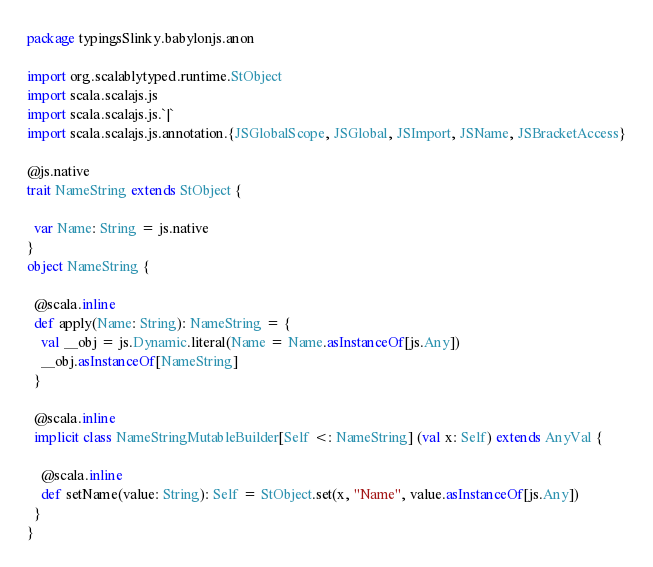Convert code to text. <code><loc_0><loc_0><loc_500><loc_500><_Scala_>package typingsSlinky.babylonjs.anon

import org.scalablytyped.runtime.StObject
import scala.scalajs.js
import scala.scalajs.js.`|`
import scala.scalajs.js.annotation.{JSGlobalScope, JSGlobal, JSImport, JSName, JSBracketAccess}

@js.native
trait NameString extends StObject {
  
  var Name: String = js.native
}
object NameString {
  
  @scala.inline
  def apply(Name: String): NameString = {
    val __obj = js.Dynamic.literal(Name = Name.asInstanceOf[js.Any])
    __obj.asInstanceOf[NameString]
  }
  
  @scala.inline
  implicit class NameStringMutableBuilder[Self <: NameString] (val x: Self) extends AnyVal {
    
    @scala.inline
    def setName(value: String): Self = StObject.set(x, "Name", value.asInstanceOf[js.Any])
  }
}
</code> 